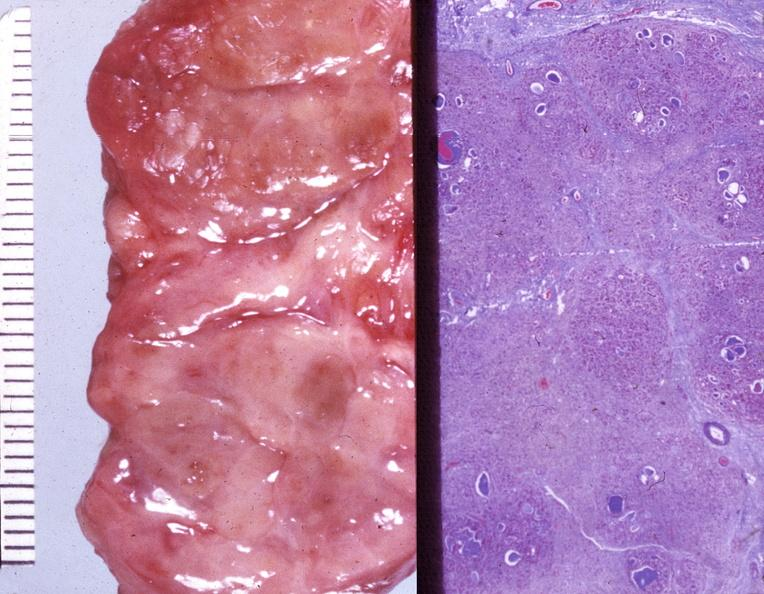what does this image show?
Answer the question using a single word or phrase. Thyroid 